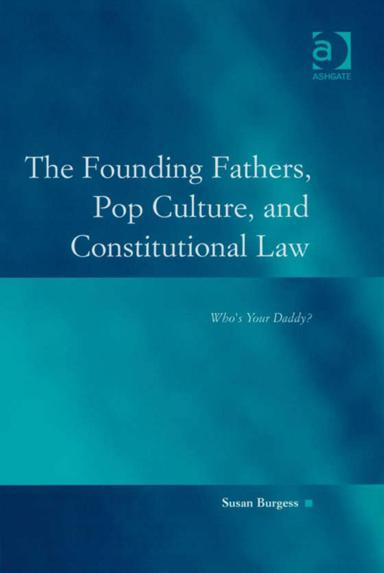What is the title of the book mentioned in the image? The book featured in the image is titled "The Founding Fathers, Pop Culture, and Constitutional Law: Who's Your Daddy" and is authored by Susan Burgess. It explores the intersection of American foundational legal principles with elements of popular culture. 